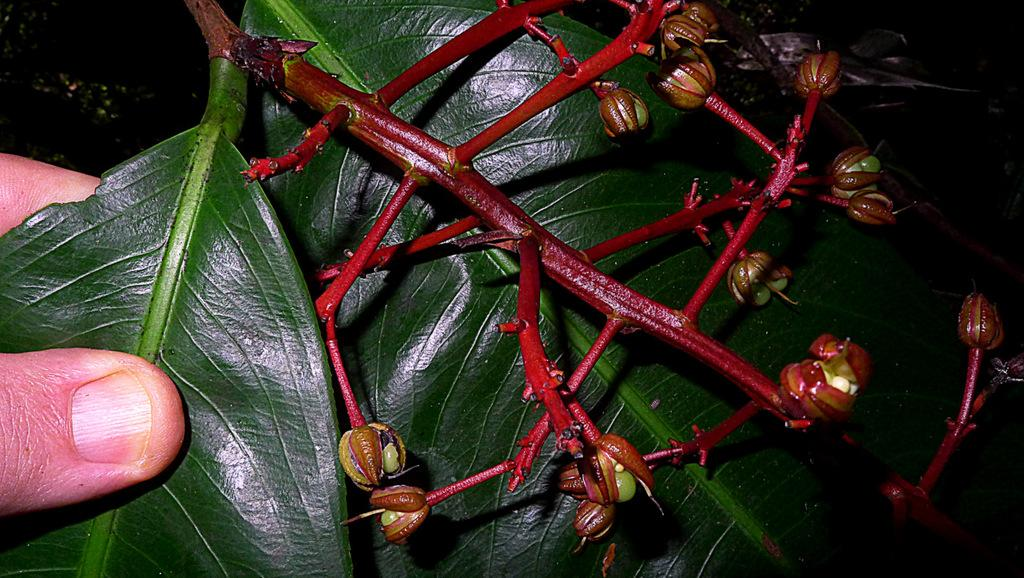What part of the plant is in bloom in the image? There is a flowering portion of a plant in the image. What type of buds can be seen on the plant? The plant has capsule-like buds with seeds inside. What other parts of the plant are visible in the image? The plant has leaves. What type of attraction can be seen in the background of the image? There is no attraction visible in the image; it only features a plant with flowering portions, capsule-like buds, and leaves. 